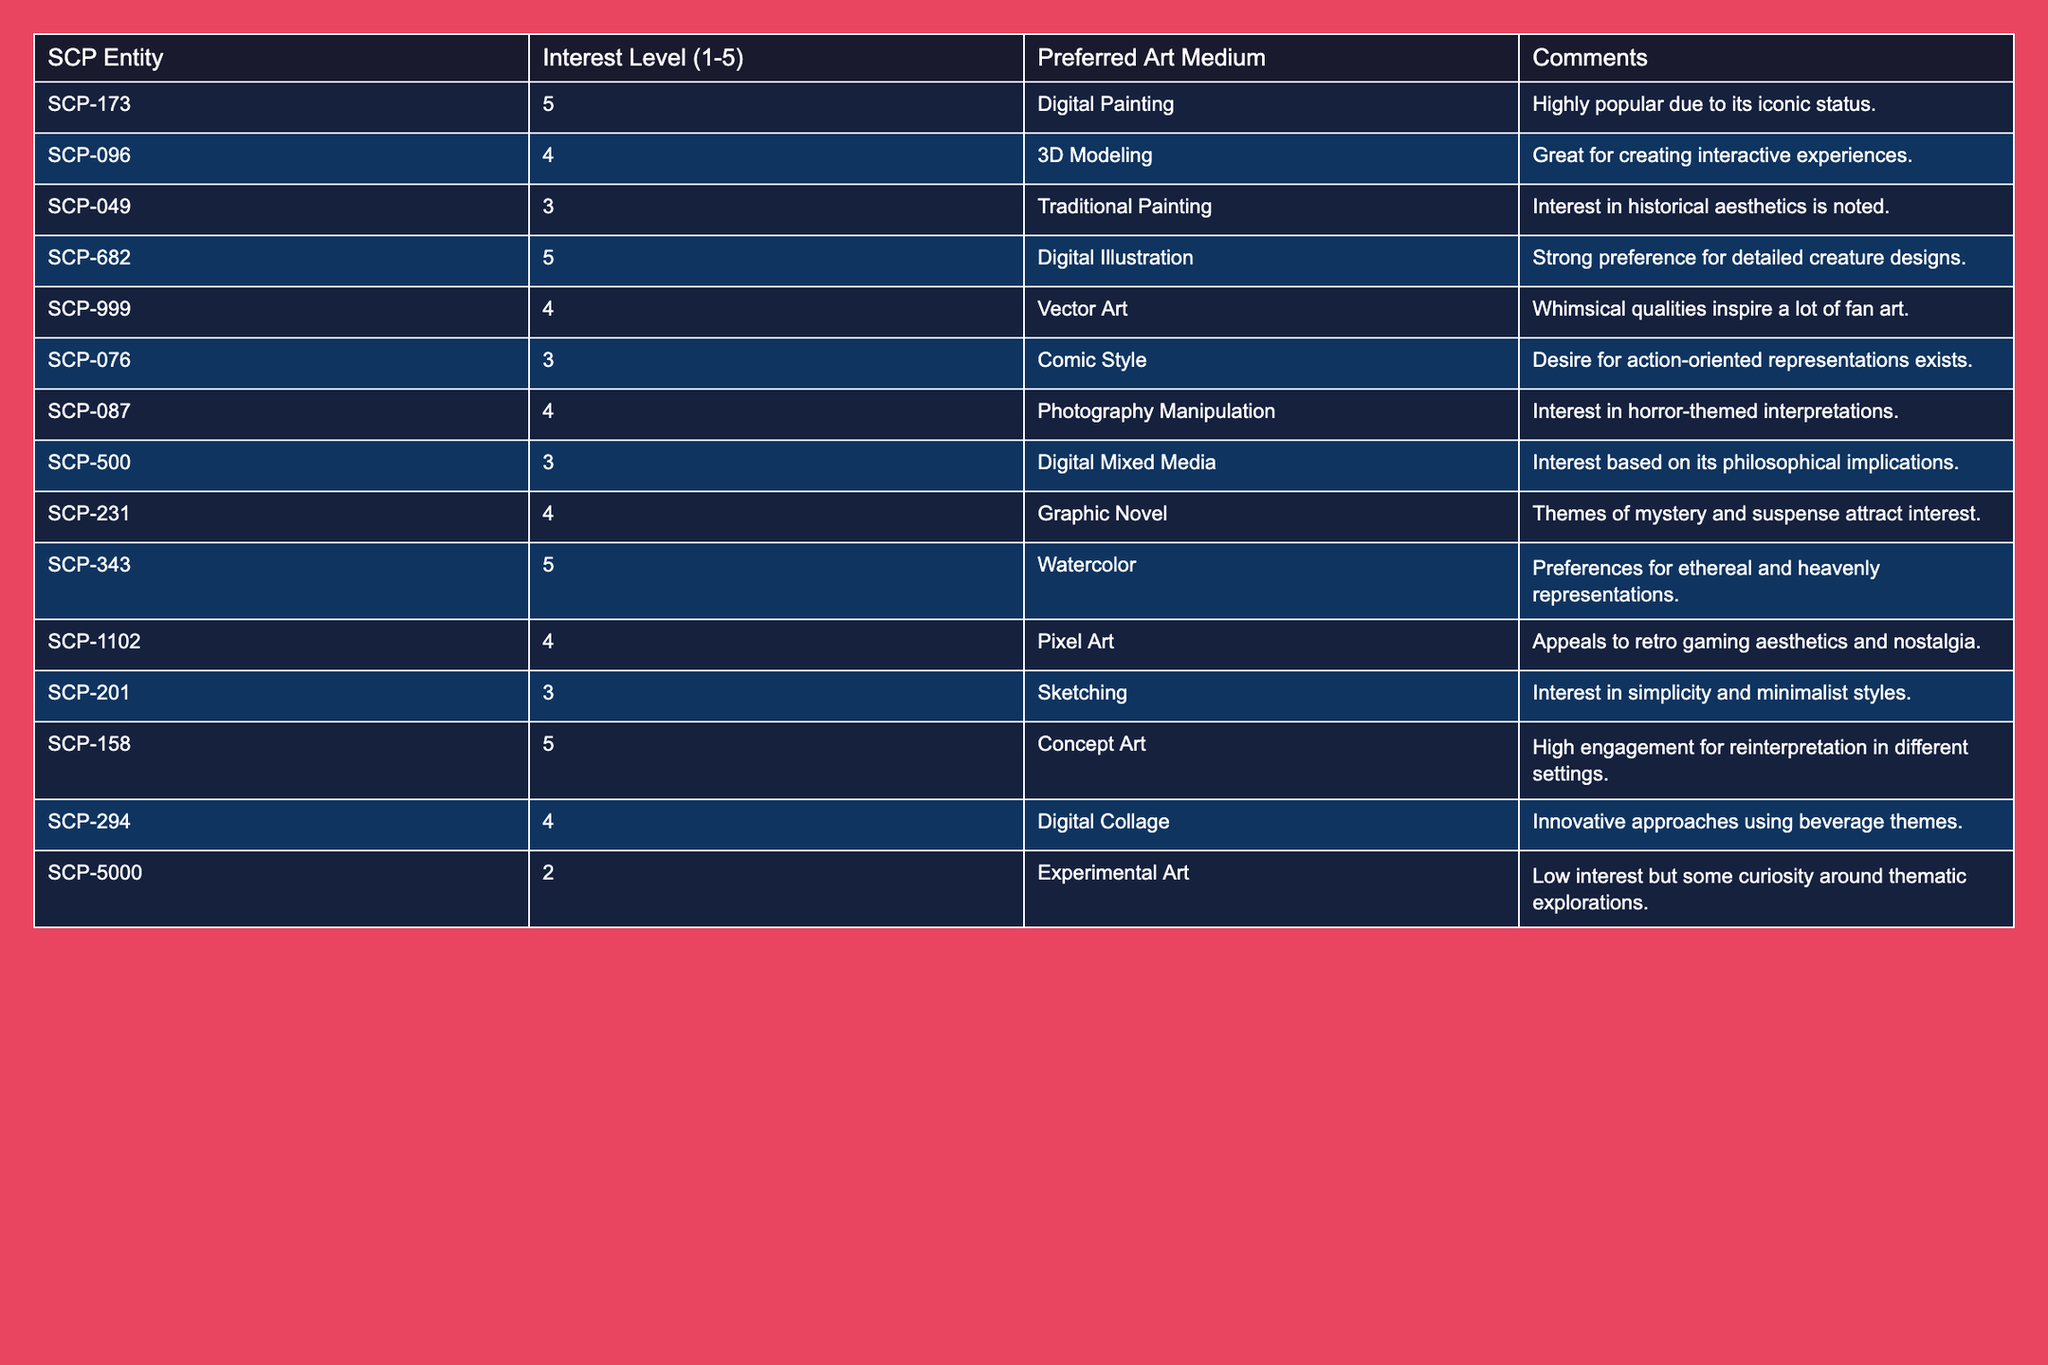What's the highest interest level recorded in the table? The interest levels range from 1 to 5. Upon inspecting the table, SCP-173, SCP-682, SCP-343, and SCP-158 all have an interest level of 5, which is the maximum.
Answer: 5 How many entities have a preferred art medium of Digital Painting? Examining the table reveals that only SCP-173 has Digital Painting listed as its preferred medium.
Answer: 1 Which SCP entity has the lowest interest level and what is that level? SCP-5000 has the lowest interest level of 2. By scanning the interest levels, it is clear that no other entity is rated lower than this.
Answer: 2 What is the preferred art medium for SCP-999? Looking at the table, SCP-999 has Vector Art listed as its preferred medium.
Answer: Vector Art Are there more entities interested in Digital Art mediums (like Digital Illustration and Digital Painting) than Traditional Art mediums? Digital mediums are represented by SCP-173 (Digital Painting), SCP-682 (Digital Illustration), and SCP-158 (Concept Art). Traditional Art has SCP-049 (Traditional Painting). Counting gives 3 for digital and 1 for traditional, confirming that digital interests are higher.
Answer: Yes What is the average interest level for the entities with an interest level of 4? The entities with an interest level of 4 are SCP-096, SCP-999, SCP-231, SCP-343, SCP-1102, and SCP-294. The sum of these interest levels is 24 (6 entities x 4), and the average is 24/6 = 4.
Answer: 4 How many entities have a preferred medium of Graphic Novel or Comic Style? SCP-231 prefers Graphic Novel and SCP-076 prefers Comic Style, making a total of 2 entities.
Answer: 2 Is there any SCP entity with an interest level of 2 that prefers an Experimental Art medium? The table shows that SCP-5000 has an interest level of 2, and its preferred medium is Experimental Art, confirming the match.
Answer: Yes Which preferred medium is associated with the highest interest level of 5? The entities at interest level 5 are SCP-173 (Digital Painting), SCP-682 (Digital Illustration), SCP-343 (Watercolor), and SCP-158 (Concept Art); thus, there are four mediums linked to interest level 5.
Answer: 4 